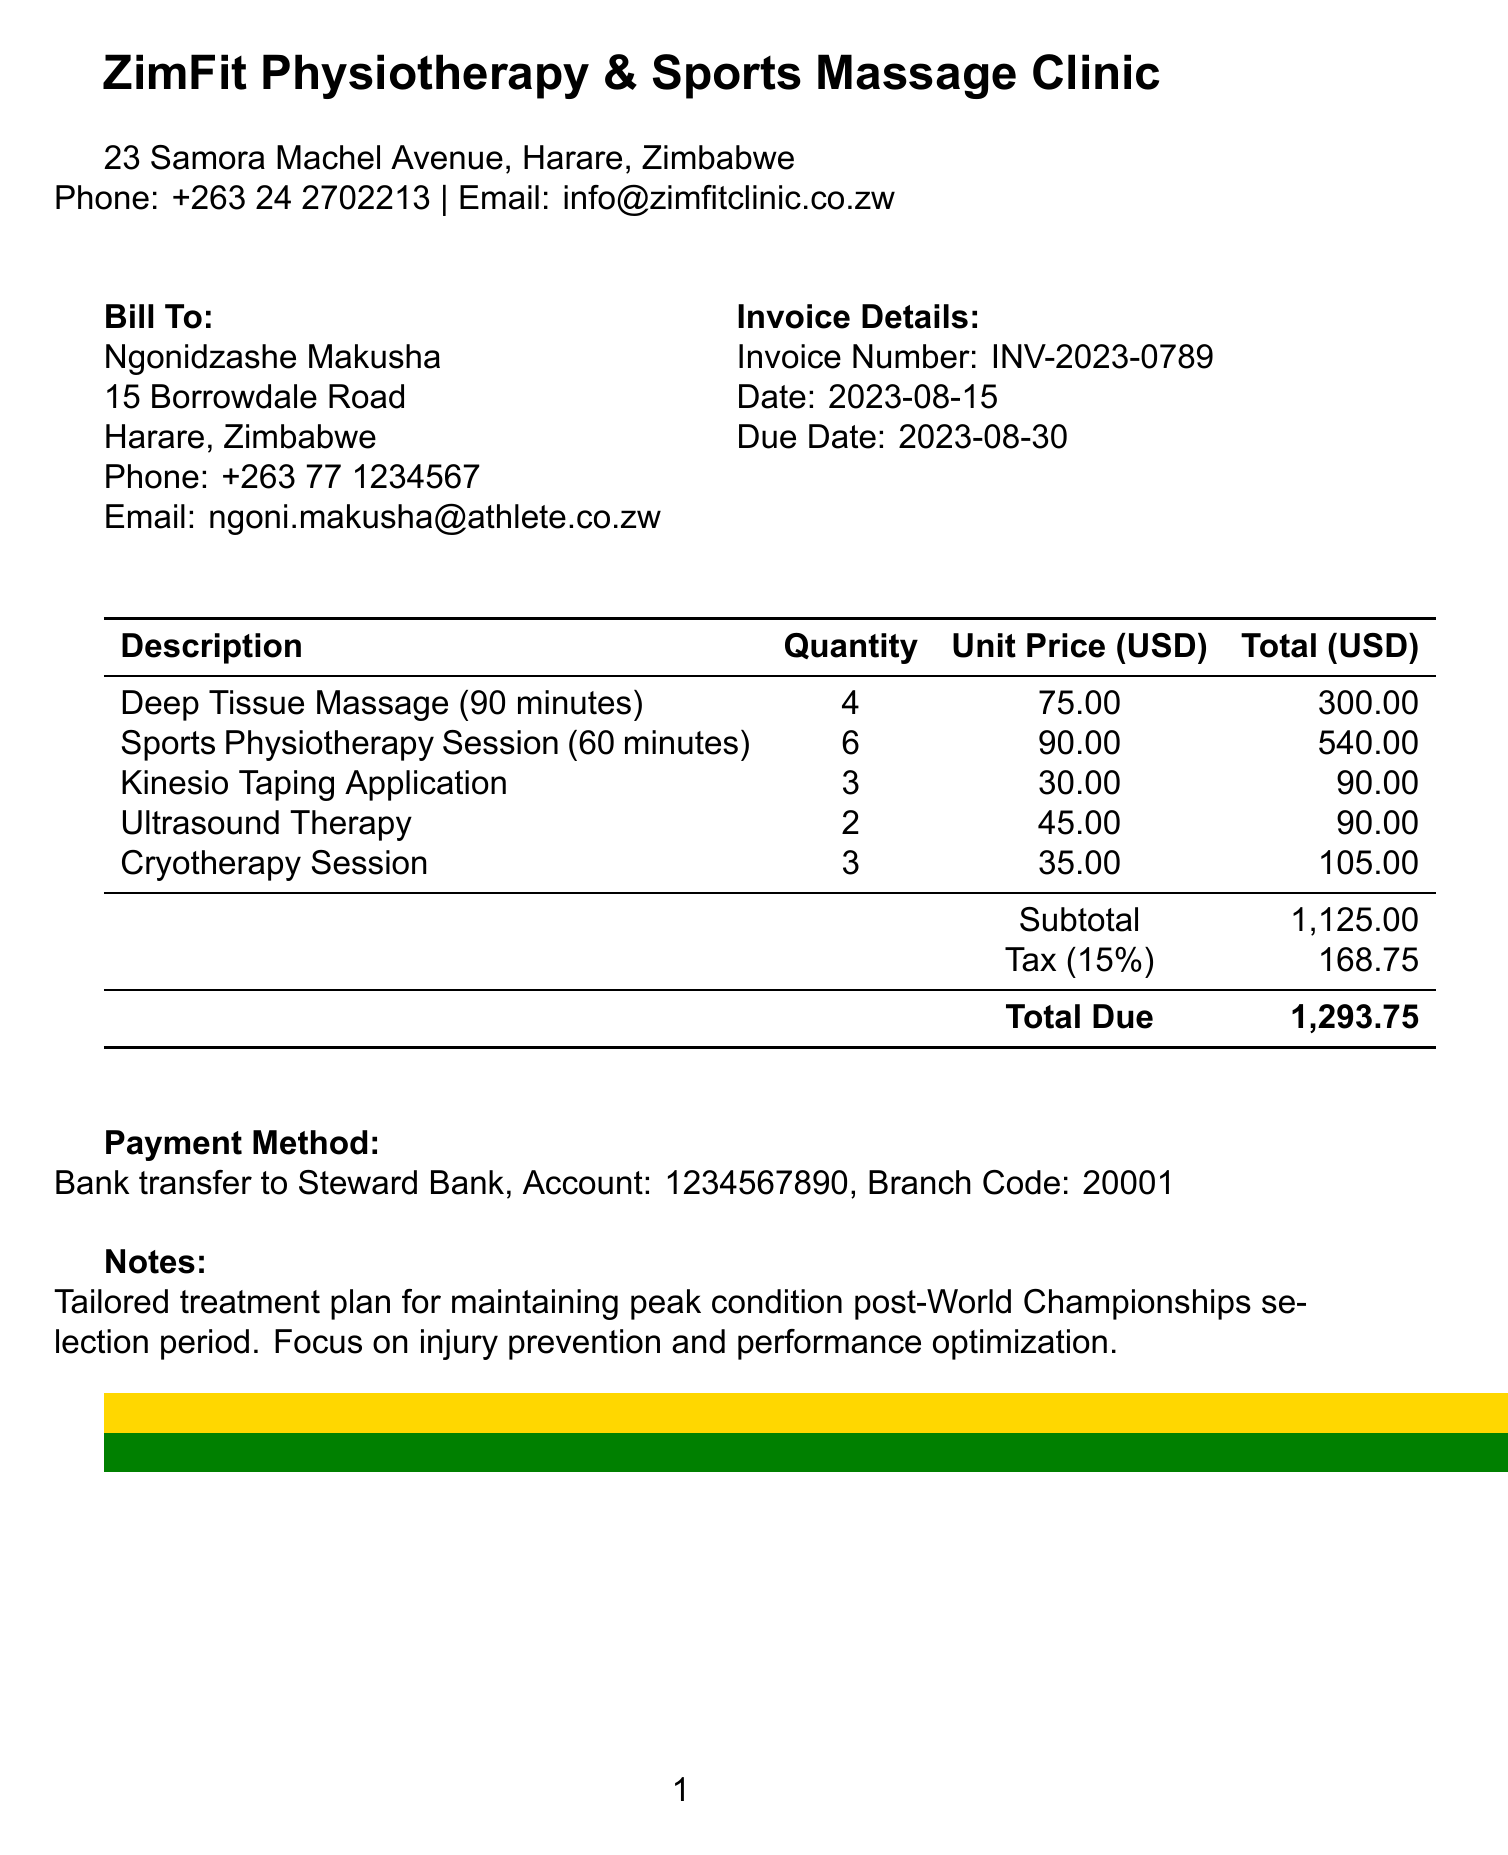What is the name of the physiotherapy provider? The document states that the physiotherapy provider is ZimFit Physiotherapy & Sports Massage Clinic.
Answer: ZimFit Physiotherapy & Sports Massage Clinic What is the invoice number? The invoice number is specified in the document as INV-2023-0789.
Answer: INV-2023-0789 What is the total amount due? The total amount due is calculated in the document as $1,293.75.
Answer: 1,293.75 How many Deep Tissue Massage sessions were billed? The document lists 4 Deep Tissue Massage sessions provided.
Answer: 4 What is the purpose of the notes in the invoice? The notes explain the treatment plan focusing on maintaining peak condition post-World Championships selection.
Answer: Tailored treatment plan for maintaining peak condition post-World Championships selection period What is the payment method specified in the invoice? The document indicates the payment method as a bank transfer to Steward Bank.
Answer: Bank transfer to Steward Bank How many total services are listed in the invoice? The document lists a total of 5 different services provided.
Answer: 5 What is the tax percentage applied to the subtotal? The tax percentage applied is mentioned as 15% in the document.
Answer: 15% What is the address of the client? The client's address is provided in the document as 15 Borrowdale Road, Harare, Zimbabwe.
Answer: 15 Borrowdale Road, Harare, Zimbabwe 